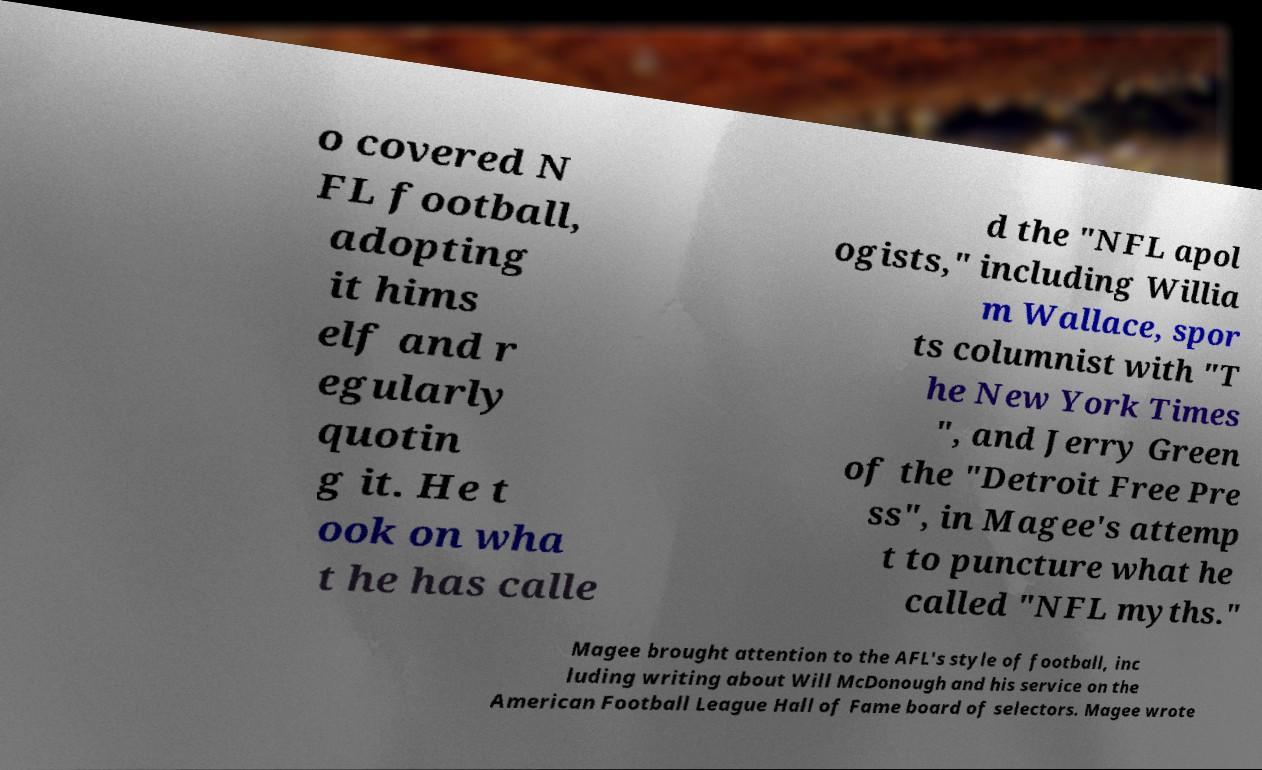Can you read and provide the text displayed in the image?This photo seems to have some interesting text. Can you extract and type it out for me? o covered N FL football, adopting it hims elf and r egularly quotin g it. He t ook on wha t he has calle d the "NFL apol ogists," including Willia m Wallace, spor ts columnist with "T he New York Times ", and Jerry Green of the "Detroit Free Pre ss", in Magee's attemp t to puncture what he called "NFL myths." Magee brought attention to the AFL's style of football, inc luding writing about Will McDonough and his service on the American Football League Hall of Fame board of selectors. Magee wrote 